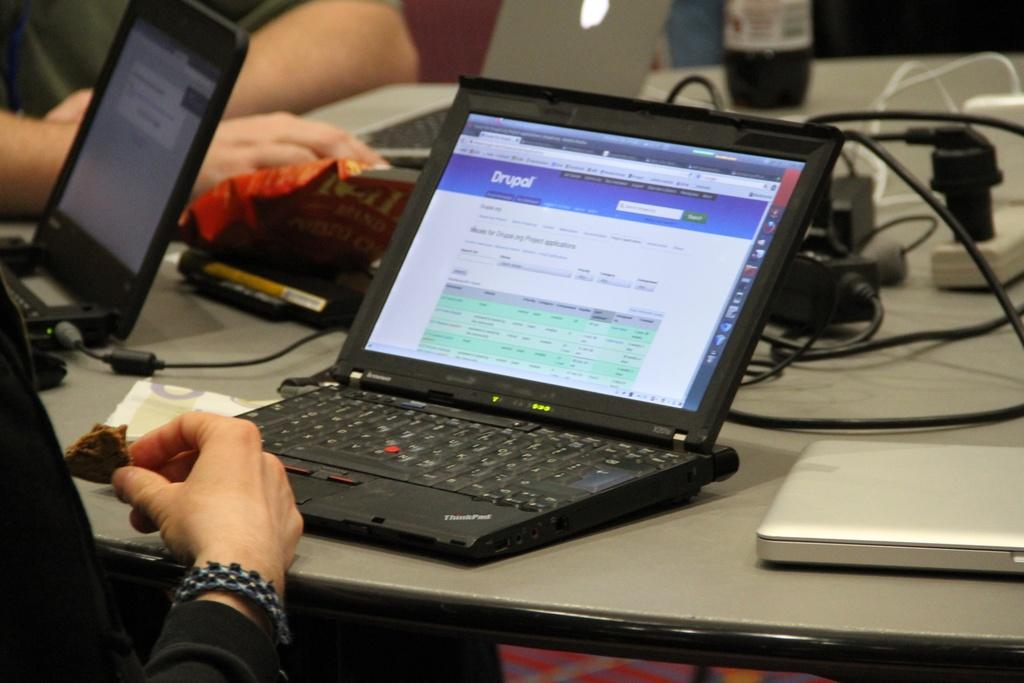What electronic device is the main subject of the image? There is a laptop in the image. Where is the laptop located? The laptop is on a desk. What other electronic device is visible in the image? There is an android mobile in the image. How is the android mobile positioned in relation to the laptop? The android mobile is beside the laptop. What type of business is being conducted in the image? There is no indication of any business being conducted in the image; it simply shows a laptop and an android mobile on a desk. 